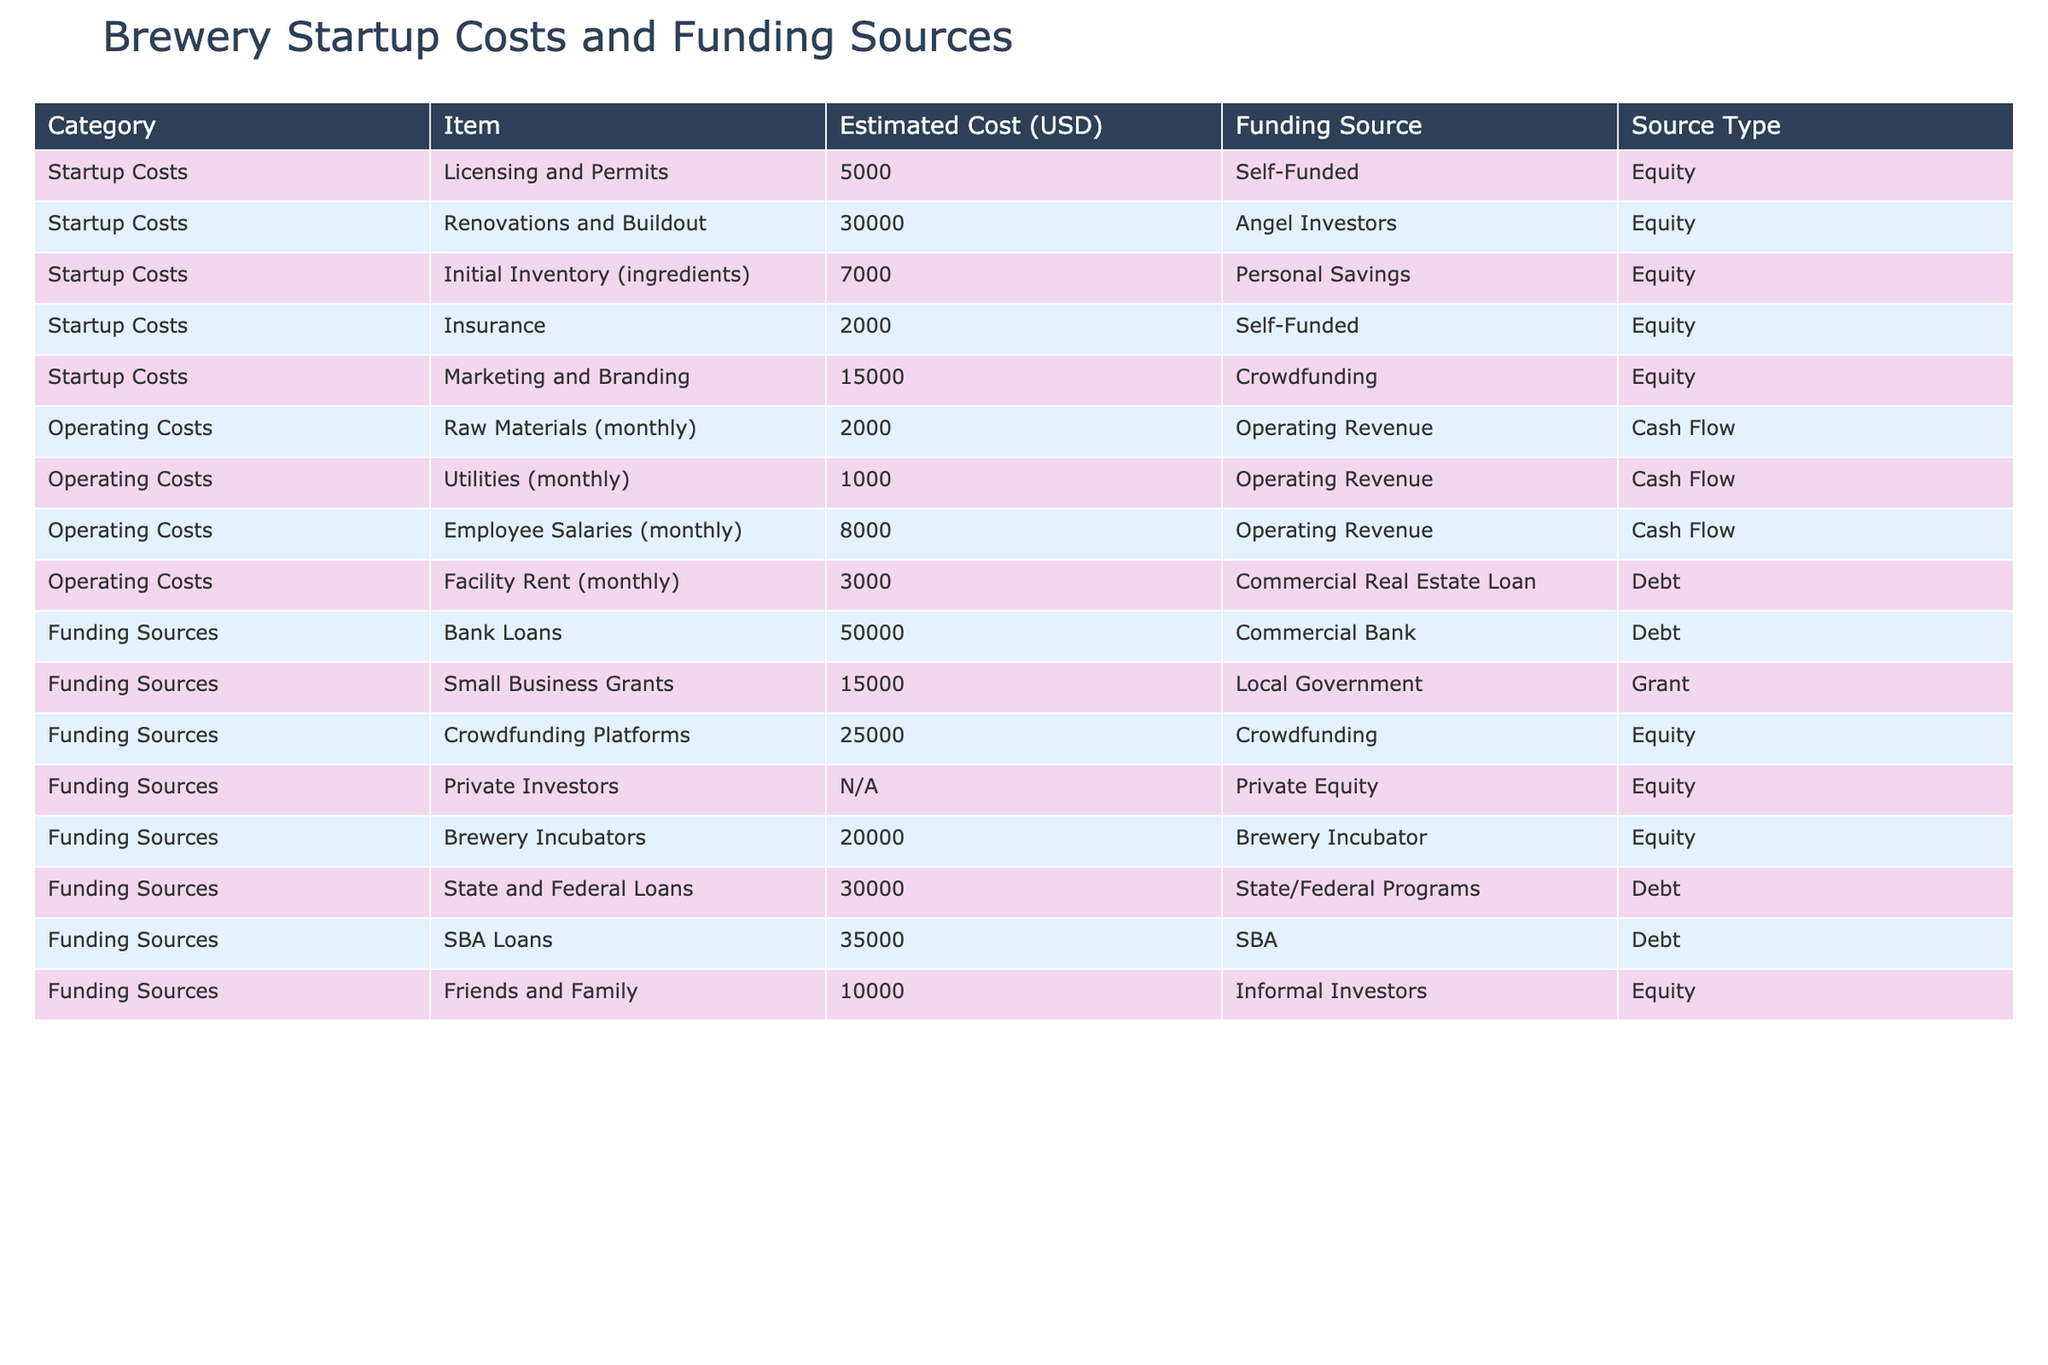What is the estimated cost for licensing and permits? The table shows a row under the "Startup Costs" category for "Licensing and Permits," which indicates an estimated cost of 5000 USD.
Answer: 5000 USD What is the largest single funding source listed in the table? By examining the "Funding Sources" section, we see that "SBA Loans" amounts to 35000 USD, making it the largest single funding source listed.
Answer: 35000 USD What is the total estimated cost of all startup costs? Summing the estimated costs of all items under the "Startup Costs" category: 5000 + 30000 + 7000 + 2000 + 15000 = 60000 USD. Thus, the total is 60000 USD.
Answer: 60000 USD Is the estimated cost of initial inventory higher than the estimated cost of insurance? The initial inventory is 7000 USD while insurance is 2000 USD. Since 7000 is greater than 2000, the answer is yes.
Answer: Yes What is the average estimated cost of operating costs listed in the table? Adding the operating costs: 2000 + 1000 + 8000 + 3000 = 14000 USD. We have 4 items, so the average is 14000 / 4 = 3500 USD.
Answer: 3500 USD How many funding sources fall under the "Debt" category? By counting the entries listed under the "Funding Sources" category that are marked as "Debt," we find four sources: Bank Loans, Facility Rent (monthly), State and Federal Loans, and SBA Loans.
Answer: 4 Which funding source requires the least amount of financial input? Checking the "Funding Sources" column, we see "Friends and Family" requires 10000 USD, which is the least amount requested compared to others listed for funding sources.
Answer: 10000 USD What are the total monthly operating costs? Adding the monthly operating costs: 2000 + 1000 + 8000 + 3000 = 14000 USD. Therefore, the total monthly operating cost is 14000 USD.
Answer: 14000 USD Do all listed funding sources in the table have defined estimated costs? Examining the table, "Private Investors" has 'N/A' for estimated cost, indicating not all funding sources have defined costs, so the answer is no.
Answer: No 